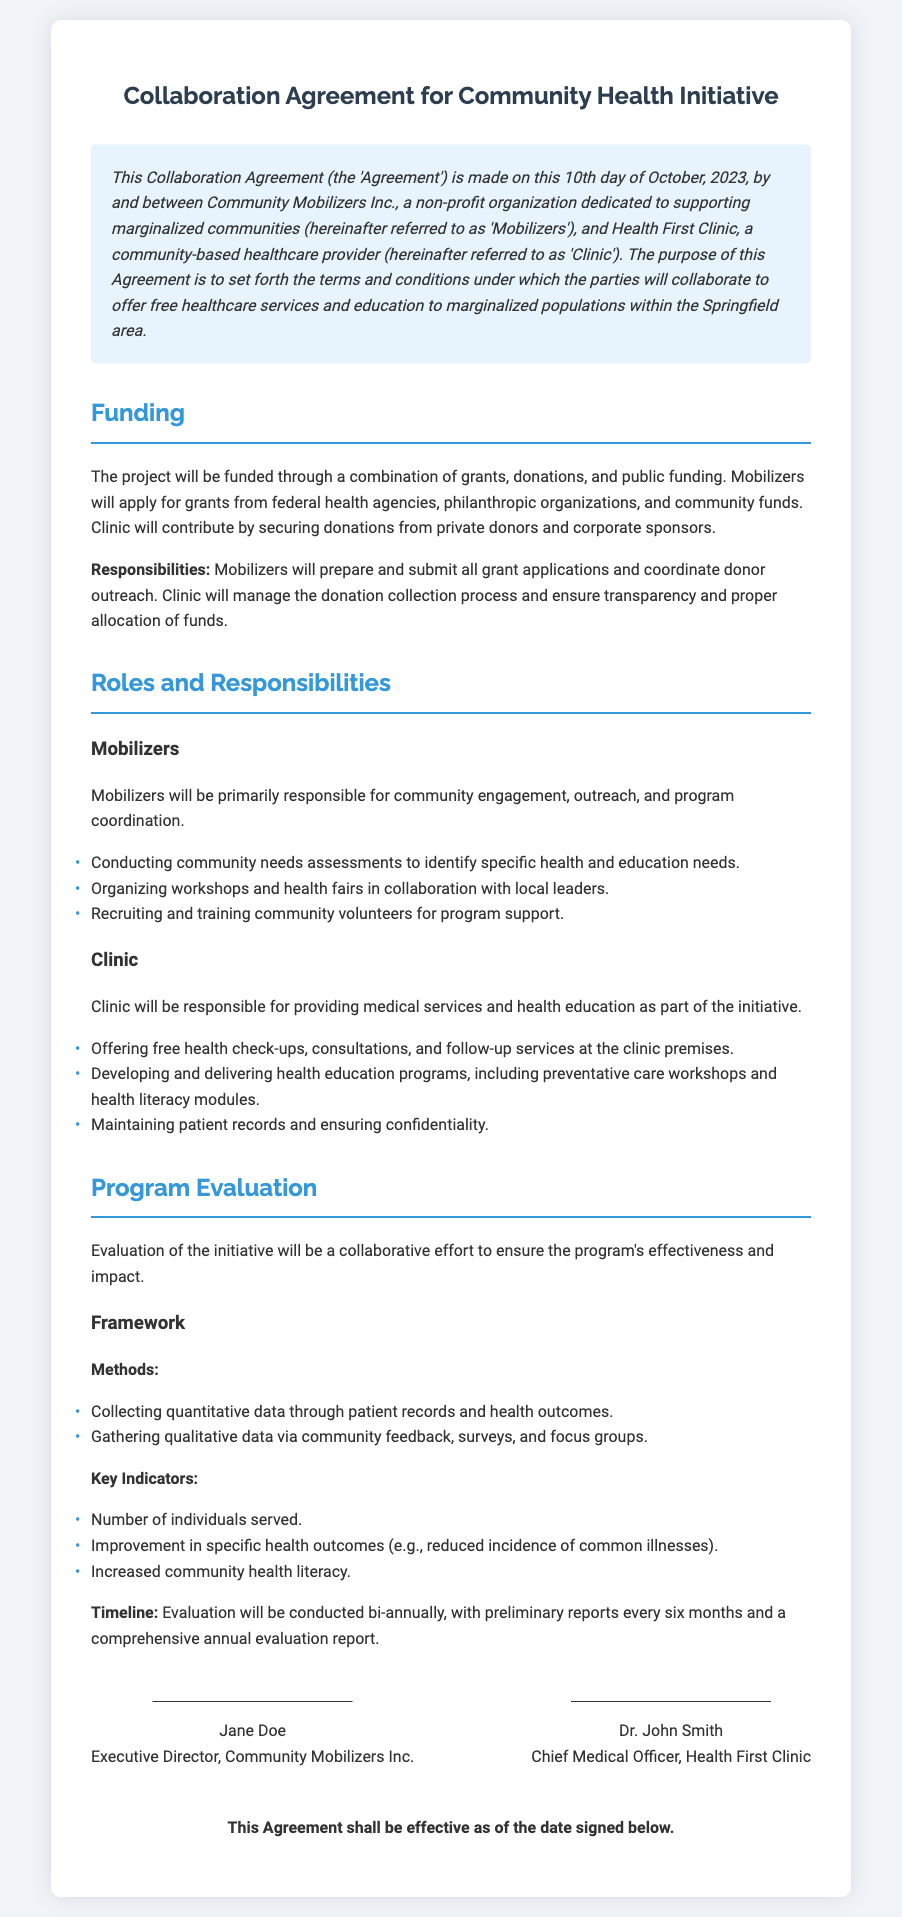What is the date of the agreement? The date of the agreement is specified in the preamble section of the document as October 10, 2023.
Answer: October 10, 2023 Who are the parties involved in this agreement? The document identifies two parties: Community Mobilizers Inc. and Health First Clinic.
Answer: Community Mobilizers Inc. and Health First Clinic What are the main responsibilities of the Mobilizers? The responsibilities of the Mobilizers, mentioned under their roles, include community engagement, outreach, and program coordination.
Answer: Community engagement, outreach, and program coordination What type of funding sources are mentioned? The funding sources listed in the document include grants, donations, and public funding.
Answer: Grants, donations, and public funding How often will the program evaluation occur? The evaluation timeline described in the document states that it will be conducted bi-annually.
Answer: Bi-annually What is the key indicator related to community health literacy? The document specifies "Increased community health literacy" as one of the key indicators for evaluation.
Answer: Increased community health literacy Who is the Chief Medical Officer of the Health First Clinic? The document names Dr. John Smith as the Chief Medical Officer of Health First Clinic.
Answer: Dr. John Smith What is the primary role of the Clinic in this initiative? According to the document, the Clinic's primary role is to provide medical services and health education.
Answer: Provide medical services and health education 